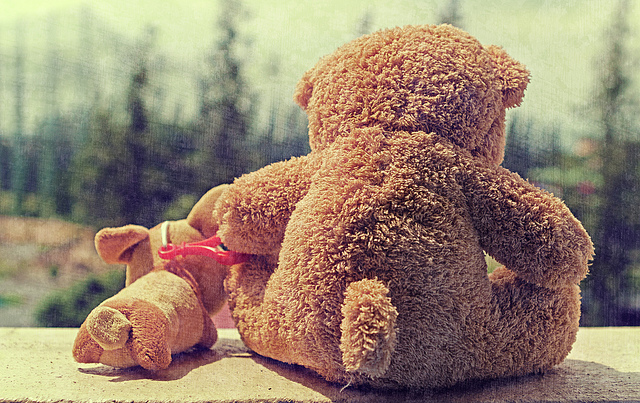Can you describe the setting in which these teddy bears are placed? The teddy bears are placed on what seems like a wooden surface with a soft-focus background that could be a garden or a forest, judging by the greenery. It's an outdoor setting with a tranquil, yet somber atmosphere, accentuated by the overcast sky, further enhancing the reflective mood of the image. 